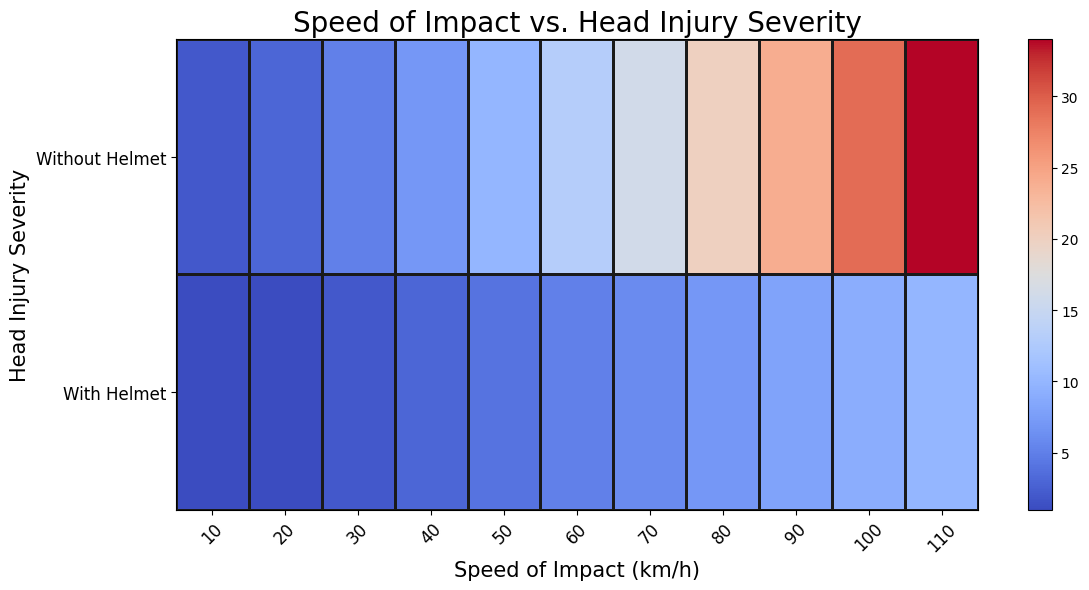What is the head injury severity at 50 km/h with and without a helmet? To answer this, look at the data points plotted for the speed of 50 km/h. Check the values corresponding to "With Helmet" and "Without Helmet." For "With Helmet," the severity value is 4, and for "Without Helmet," it's 10.
Answer: With Helmet: 4, Without Helmet: 10 How much higher is the head injury severity without a helmet than with a helmet at 80 km/h? First, find the severity values at 80 km/h for both "With Helmet" and "Without Helmet." The values are 7 and 20, respectively. Then subtract the helmet severity from the non-helmet severity, resulting in 20 - 7.
Answer: 13 At which speed does the severity difference between wearing and not wearing a helmet become greater than 10? Examine the severities at each speed. Calculate the differences (Without Helmet - With Helmet). At 50 km/h, the difference (10 - 4) is 6. At 60 km/h, the difference (13 - 5) is 8. And so on. First occurrence is at 70 km/h (16 - 6 = 10).
Answer: 70 km/h What trend can be observed in the extent of head injury with increasing speed for motorcyclists not wearing helmets? Review how the severity values change for "Without Helmet" as the speed increases. It shows a clear upward trend, meaning the severity of head injuries increases with speed.
Answer: Increasing trend What is the average head injury severity at 30 km/h, 60 km/h, and 90 km/h for motorcyclists with helmets? Identify severities for 30 km/h, 60 km/h, and 90 km/h with helmets (2, 5, and 8). Calculate the average: \( \frac{2 + 5 + 8}{3} = 5 \)
Answer: 5 Compare the head injury severities at the lowest and highest speeds for motorcyclists with and without helmets. Check the severities at 10 km/h and 110 km/h. With helmets: 1 (10 km/h), 10 (110 km/h). Without helmets: 2 (10 km/h), 34 (110 km/h).
Answer: With Helmet: 1 and 10, Without Helmet: 2 and 34 What is the color difference observed between the severities with and without a helmet at higher speeds? Look at the color gradient on the plot for higher speeds (e.g., 90 km/h, 100 km/h, and 110 km/h). The severity for "Without Helmet" is represented by a much darker color than for "With Helmet."
Answer: Darker without helmet Which speed shows the first instance where head injury severity without a helmet doubles the severity with a helmet? Look for speeds where the severity without a helmet is twice the severity with a helmet. At 20 km/h, the severity without helmet (3) is greater than twice with helmet (1). Confirm.
Answer: 20 km/h How does the color transition in the heatmap reflect the increasing severity levels? Observe the gradient transitions in the heatmap. As severities increase, the color shifts from lighter shades to darker, indicating higher severity of head injuries.
Answer: From light to dark 